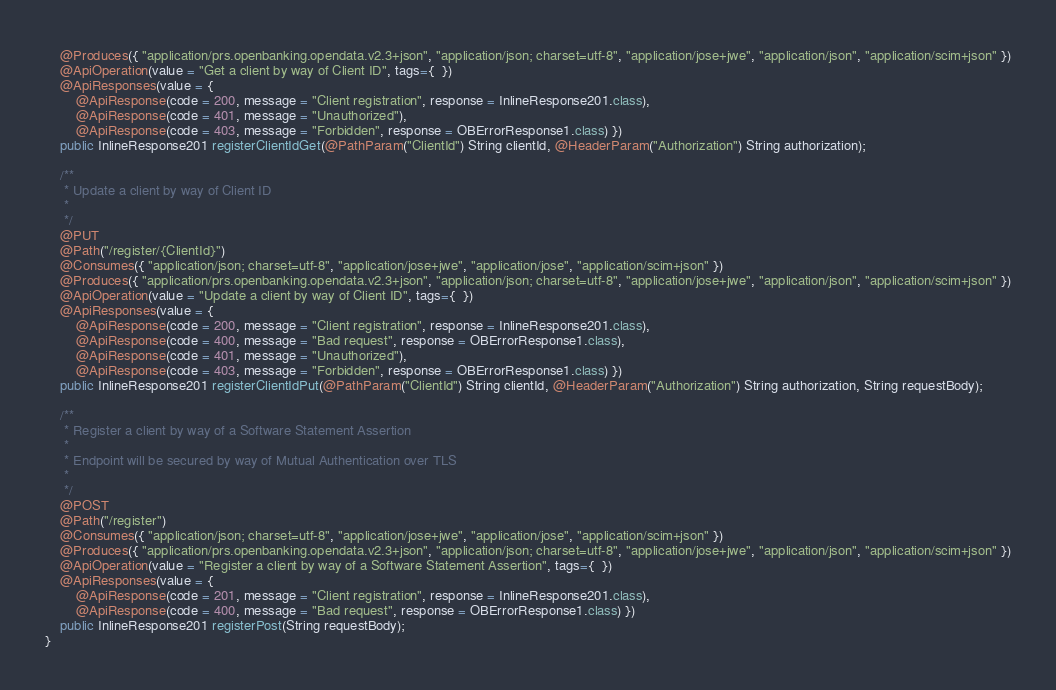Convert code to text. <code><loc_0><loc_0><loc_500><loc_500><_Java_>    @Produces({ "application/prs.openbanking.opendata.v2.3+json", "application/json; charset=utf-8", "application/jose+jwe", "application/json", "application/scim+json" })
    @ApiOperation(value = "Get a client by way of Client ID", tags={  })
    @ApiResponses(value = { 
        @ApiResponse(code = 200, message = "Client registration", response = InlineResponse201.class),
        @ApiResponse(code = 401, message = "Unauthorized"),
        @ApiResponse(code = 403, message = "Forbidden", response = OBErrorResponse1.class) })
    public InlineResponse201 registerClientIdGet(@PathParam("ClientId") String clientId, @HeaderParam("Authorization") String authorization);

    /**
     * Update a client by way of Client ID
     *
     */
    @PUT
    @Path("/register/{ClientId}")
    @Consumes({ "application/json; charset=utf-8", "application/jose+jwe", "application/jose", "application/scim+json" })
    @Produces({ "application/prs.openbanking.opendata.v2.3+json", "application/json; charset=utf-8", "application/jose+jwe", "application/json", "application/scim+json" })
    @ApiOperation(value = "Update a client by way of Client ID", tags={  })
    @ApiResponses(value = { 
        @ApiResponse(code = 200, message = "Client registration", response = InlineResponse201.class),
        @ApiResponse(code = 400, message = "Bad request", response = OBErrorResponse1.class),
        @ApiResponse(code = 401, message = "Unauthorized"),
        @ApiResponse(code = 403, message = "Forbidden", response = OBErrorResponse1.class) })
    public InlineResponse201 registerClientIdPut(@PathParam("ClientId") String clientId, @HeaderParam("Authorization") String authorization, String requestBody);

    /**
     * Register a client by way of a Software Statement Assertion
     *
     * Endpoint will be secured by way of Mutual Authentication over TLS
     *
     */
    @POST
    @Path("/register")
    @Consumes({ "application/json; charset=utf-8", "application/jose+jwe", "application/jose", "application/scim+json" })
    @Produces({ "application/prs.openbanking.opendata.v2.3+json", "application/json; charset=utf-8", "application/jose+jwe", "application/json", "application/scim+json" })
    @ApiOperation(value = "Register a client by way of a Software Statement Assertion", tags={  })
    @ApiResponses(value = { 
        @ApiResponse(code = 201, message = "Client registration", response = InlineResponse201.class),
        @ApiResponse(code = 400, message = "Bad request", response = OBErrorResponse1.class) })
    public InlineResponse201 registerPost(String requestBody);
}

</code> 